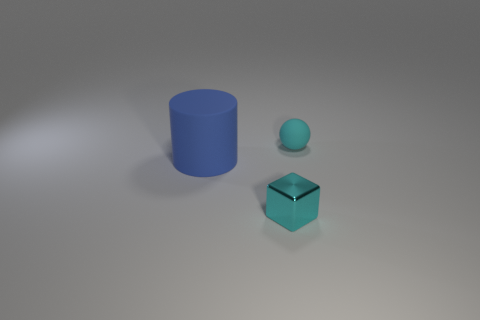What material do the objects appear to be made of, and can you describe their surfaces? The objects all appear to have a matte finish. The blue cylinder and the blue sphere have a consistent, smooth surface, while the turquoise cube has a reflective surface that suggests a slightly different, perhaps glossier material. Can you tell if the lighting in the image is natural or artificial? The lighting in the image appears to be artificial, as indicated by the consistent and soft shadows cast by the objects, which suggest a source of light that is uniform and diffused, like a studio light. 